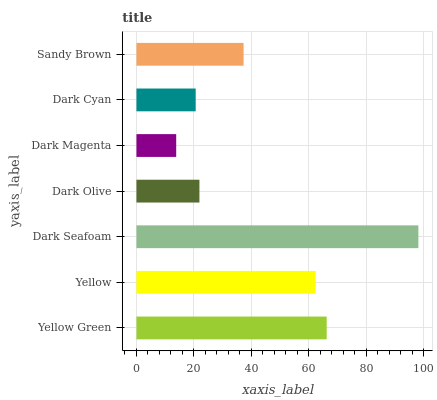Is Dark Magenta the minimum?
Answer yes or no. Yes. Is Dark Seafoam the maximum?
Answer yes or no. Yes. Is Yellow the minimum?
Answer yes or no. No. Is Yellow the maximum?
Answer yes or no. No. Is Yellow Green greater than Yellow?
Answer yes or no. Yes. Is Yellow less than Yellow Green?
Answer yes or no. Yes. Is Yellow greater than Yellow Green?
Answer yes or no. No. Is Yellow Green less than Yellow?
Answer yes or no. No. Is Sandy Brown the high median?
Answer yes or no. Yes. Is Sandy Brown the low median?
Answer yes or no. Yes. Is Dark Cyan the high median?
Answer yes or no. No. Is Dark Magenta the low median?
Answer yes or no. No. 